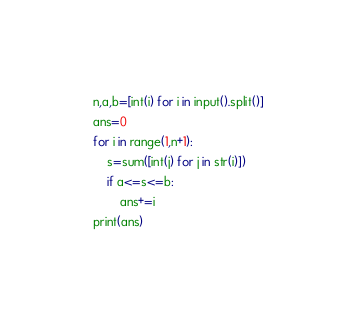Convert code to text. <code><loc_0><loc_0><loc_500><loc_500><_Python_>n,a,b=[int(i) for i in input().split()]
ans=0
for i in range(1,n+1):
    s=sum([int(j) for j in str(i)])
    if a<=s<=b:
        ans+=i
print(ans)</code> 